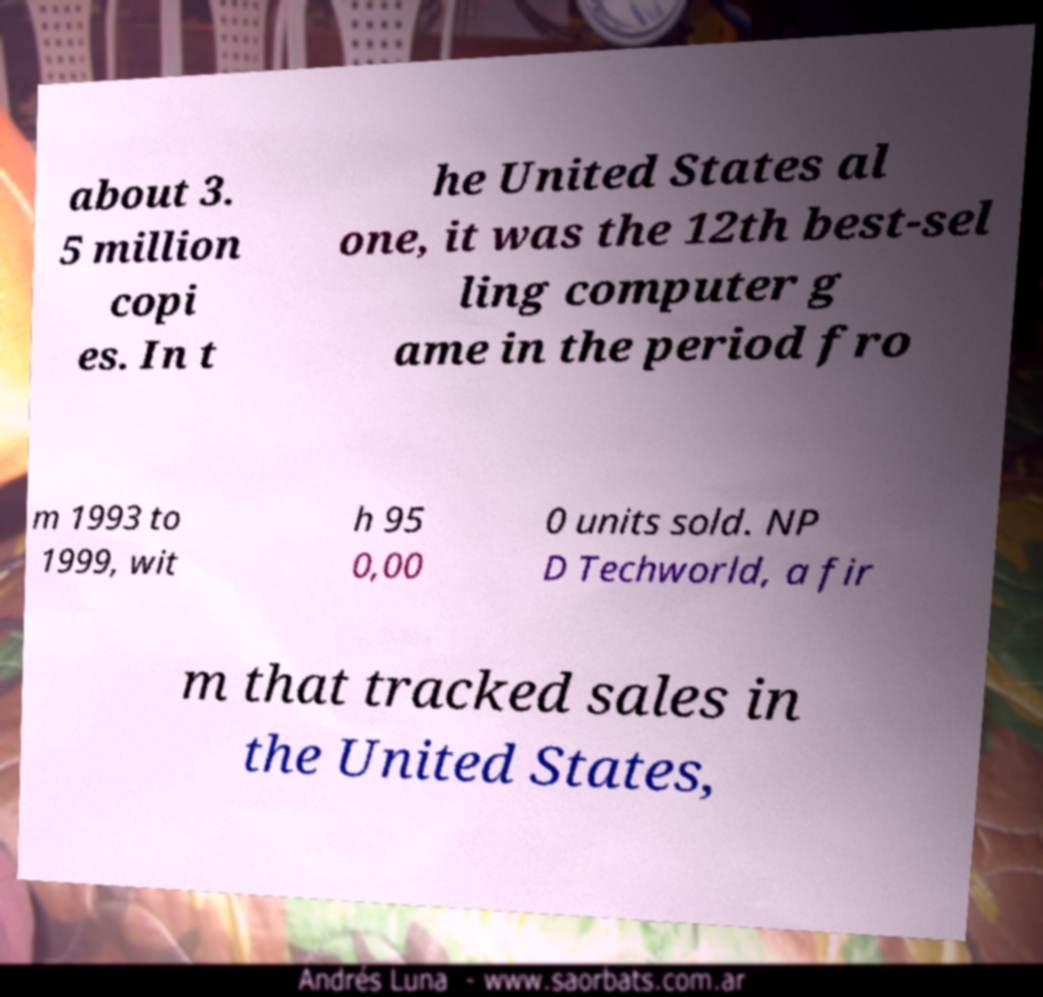Could you assist in decoding the text presented in this image and type it out clearly? about 3. 5 million copi es. In t he United States al one, it was the 12th best-sel ling computer g ame in the period fro m 1993 to 1999, wit h 95 0,00 0 units sold. NP D Techworld, a fir m that tracked sales in the United States, 